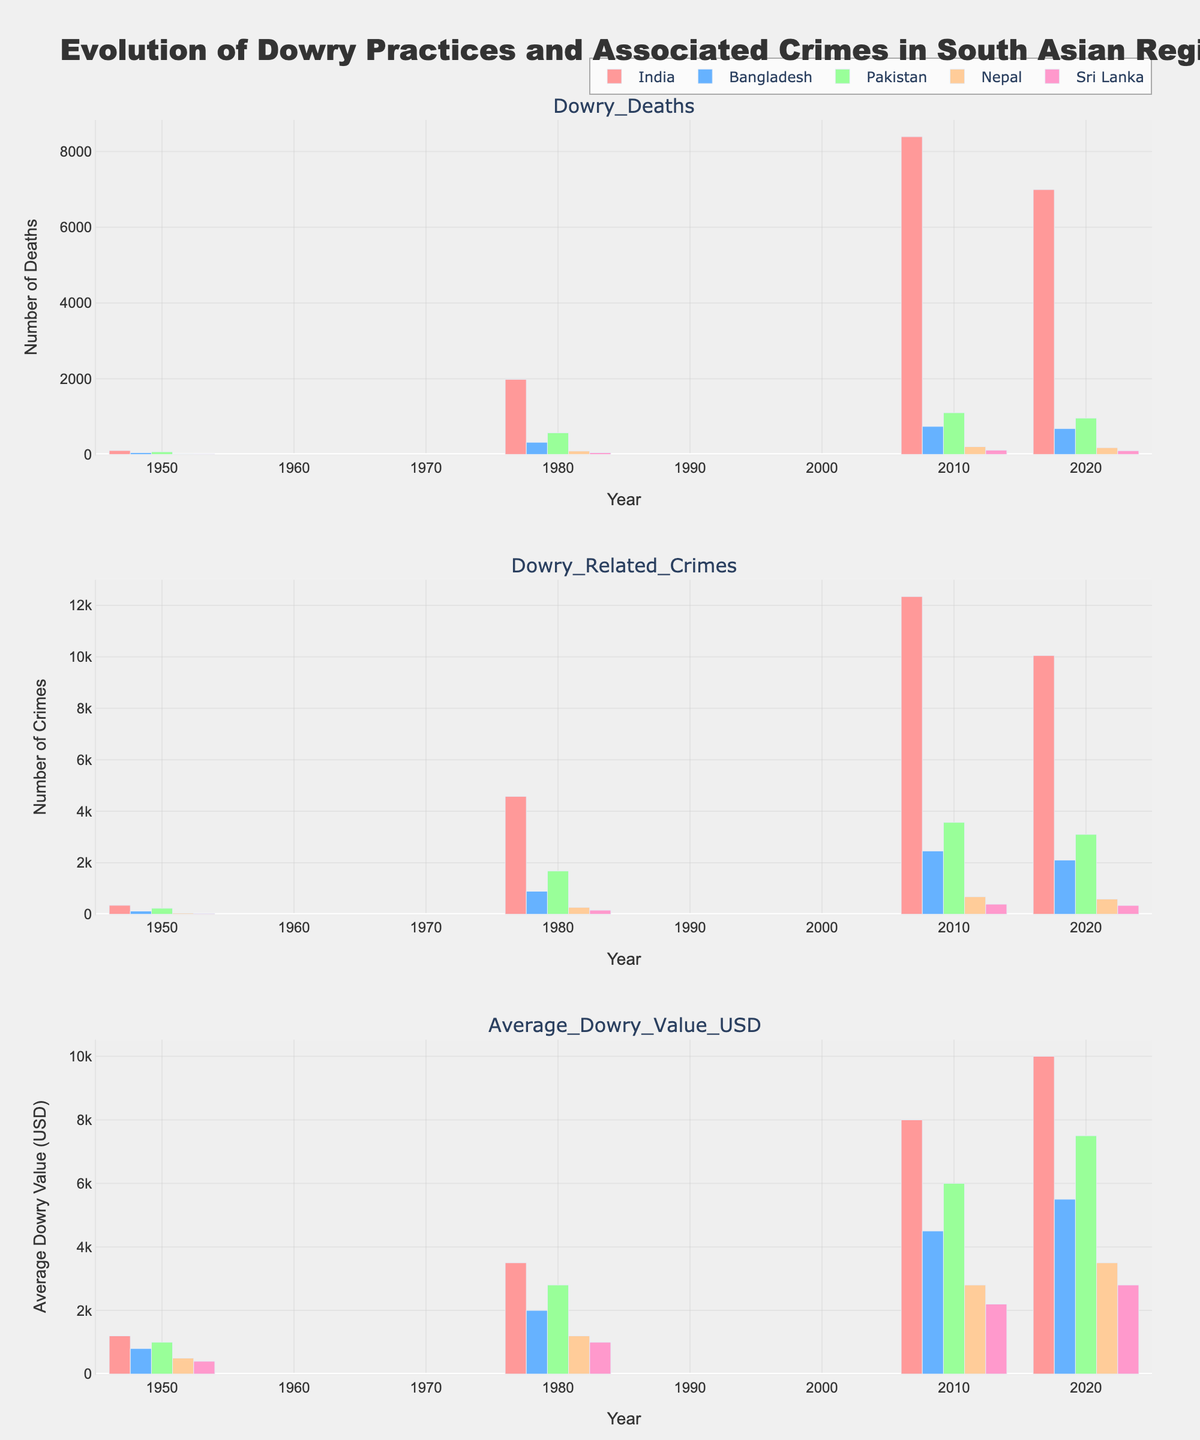What's the average dowry value in India in the years 1980, 2010, and 2020? To find the average dowry value in India for these years, we locate the respective bars in the "Average Dowry Value (USD)" subplot for India. The values are $3500 for 1980, $8000 for 2010, and $10000 for 2020. Then we average these values: ($3500 + $8000 + $10000) / 3 = $7150.
Answer: $7150 Which country has the highest number of dowry-related crimes in 2010? To determine this, we examine the "Dowry Related Crimes" subplot and compare the heights of the bars for 2010 across all countries. India has the tallest bar with 12345 crimes for that year, which is the highest.
Answer: India How did the number of dowry deaths in Bangladesh change from 1950 to 2020? Looking at the "Dowry Deaths" subplot, we compare the heights of the bars representing Bangladesh for 1950 and 2020. In 1950, there were 45 deaths, and in 2020, there were 682. The number increased significantly by 637 deaths.
Answer: Increased by 637 What is the overall trend in average dowry value in Pakistan from 1950 to 2020? We observe the "Average Dowry Value (USD)" subplot for Pakistan. The values for Pakistan are increasing from $1000 in 1950 to $7500 in 2020. This indicates an overall upward trend over these years.
Answer: Upward trend Which region had the smallest change in dowry-related crimes between 1980 and 2020? We examine the "Dowry Related Crimes" subplot and calculate the changes for each region between 1980 and 2020. The differences are: India (10050-4578=5472), Bangladesh (2100-890=1210), Pakistan (3100-1678=1422), Nepal (590-267=323), Sri Lanka (340-156=184). Sri Lanka had the smallest change with an increase of only 184 crimes.
Answer: Sri Lanka Compare the average dowry value in 1950 and 2020 for Nepal. What is the percentage increase? From the "Average Dowry Value (USD)" subplot, Nepal's values are $500 in 1950 and $3500 in 2020. The percentage increase is calculated as ((3500 - 500) / 500) * 100 = 600%.
Answer: 600% In what year and region did dowry deaths peak in India? In the "Dowry Deaths" subplot for India, the peak occurs when the bar is tallest. In 2010, dowry deaths for India were at their highest at 8391.
Answer: 2010 What is the difference in average dowry value between India and Sri Lanka in 2020? We examine the "Average Dowry Value (USD)" subplot and find the values for 2020. For India, it's $10000, and for Sri Lanka, it's $2800. The difference is $10000 - $2800 = $7200.
Answer: $7200 Which country shows a significant drop in dowry deaths from 2010 to 2020? Looking at the "Dowry Deaths" subplot, we compare the bars for 2010 and 2020. India shows a significant drop from 8391 deaths in 2010 to 6995 in 2020, a decrease of 1396 deaths.
Answer: India 